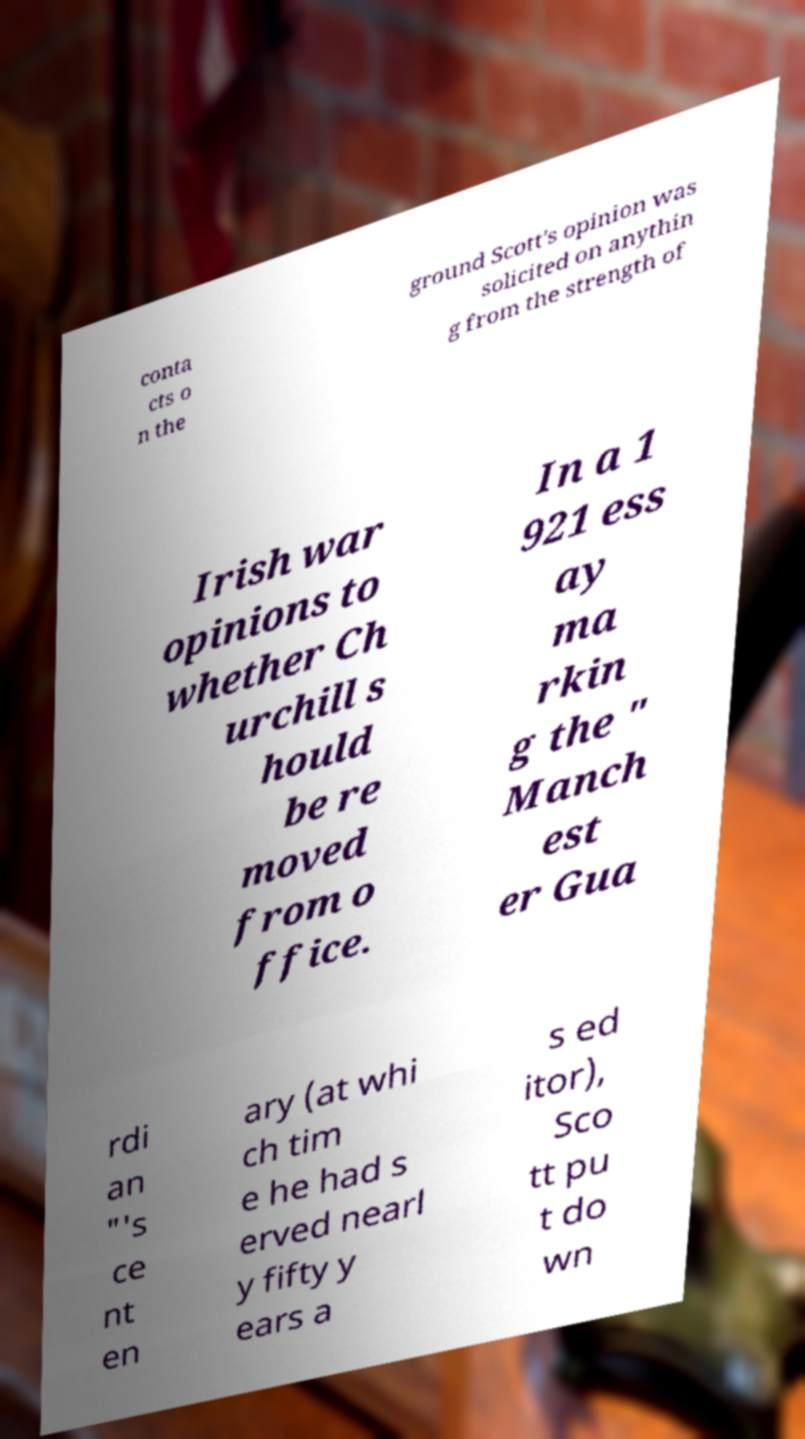I need the written content from this picture converted into text. Can you do that? conta cts o n the ground Scott's opinion was solicited on anythin g from the strength of Irish war opinions to whether Ch urchill s hould be re moved from o ffice. In a 1 921 ess ay ma rkin g the " Manch est er Gua rdi an "'s ce nt en ary (at whi ch tim e he had s erved nearl y fifty y ears a s ed itor), Sco tt pu t do wn 